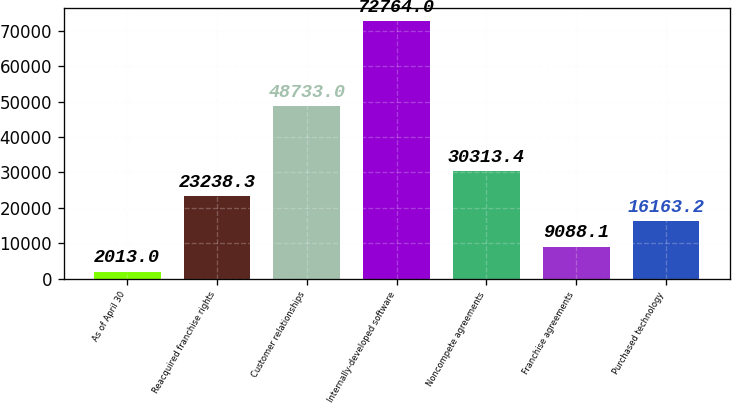<chart> <loc_0><loc_0><loc_500><loc_500><bar_chart><fcel>As of April 30<fcel>Reacquired franchise rights<fcel>Customer relationships<fcel>Internally-developed software<fcel>Noncompete agreements<fcel>Franchise agreements<fcel>Purchased technology<nl><fcel>2013<fcel>23238.3<fcel>48733<fcel>72764<fcel>30313.4<fcel>9088.1<fcel>16163.2<nl></chart> 